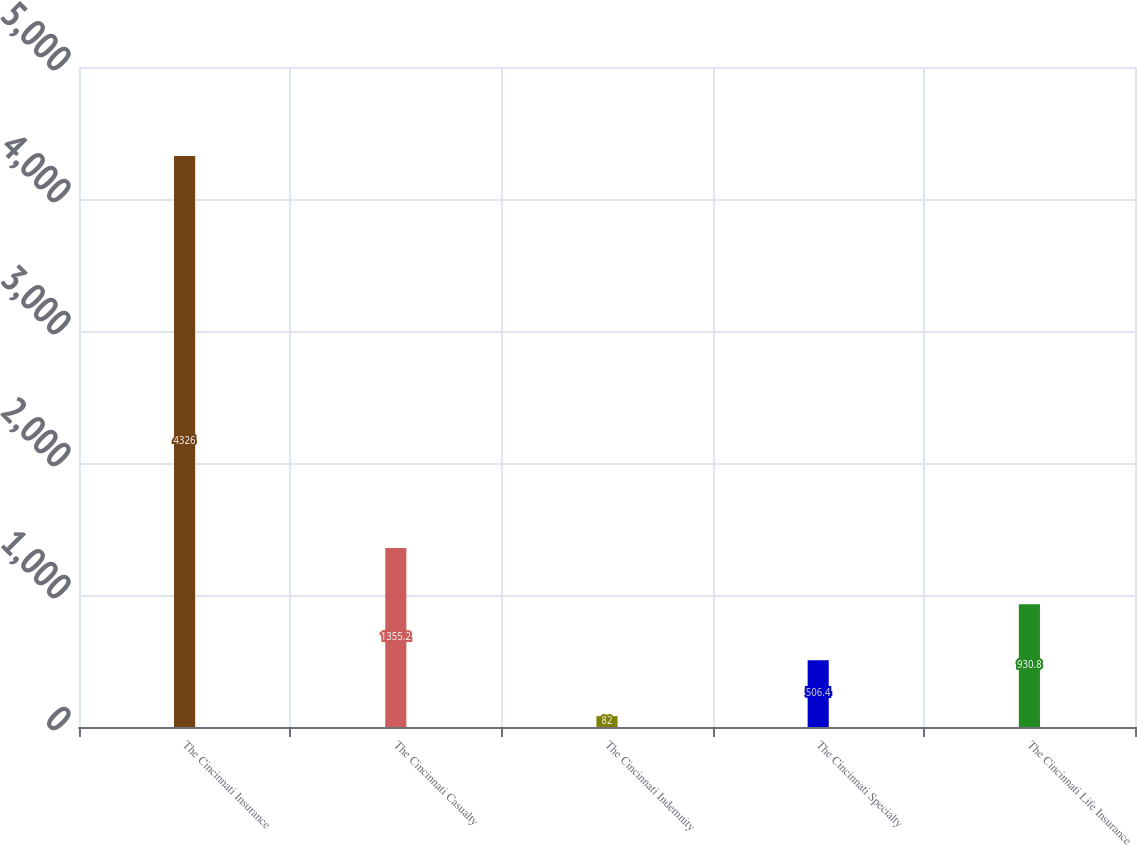Convert chart. <chart><loc_0><loc_0><loc_500><loc_500><bar_chart><fcel>The Cincinnati Insurance<fcel>The Cincinnati Casualty<fcel>The Cincinnati Indemnity<fcel>The Cincinnati Specialty<fcel>The Cincinnati Life Insurance<nl><fcel>4326<fcel>1355.2<fcel>82<fcel>506.4<fcel>930.8<nl></chart> 